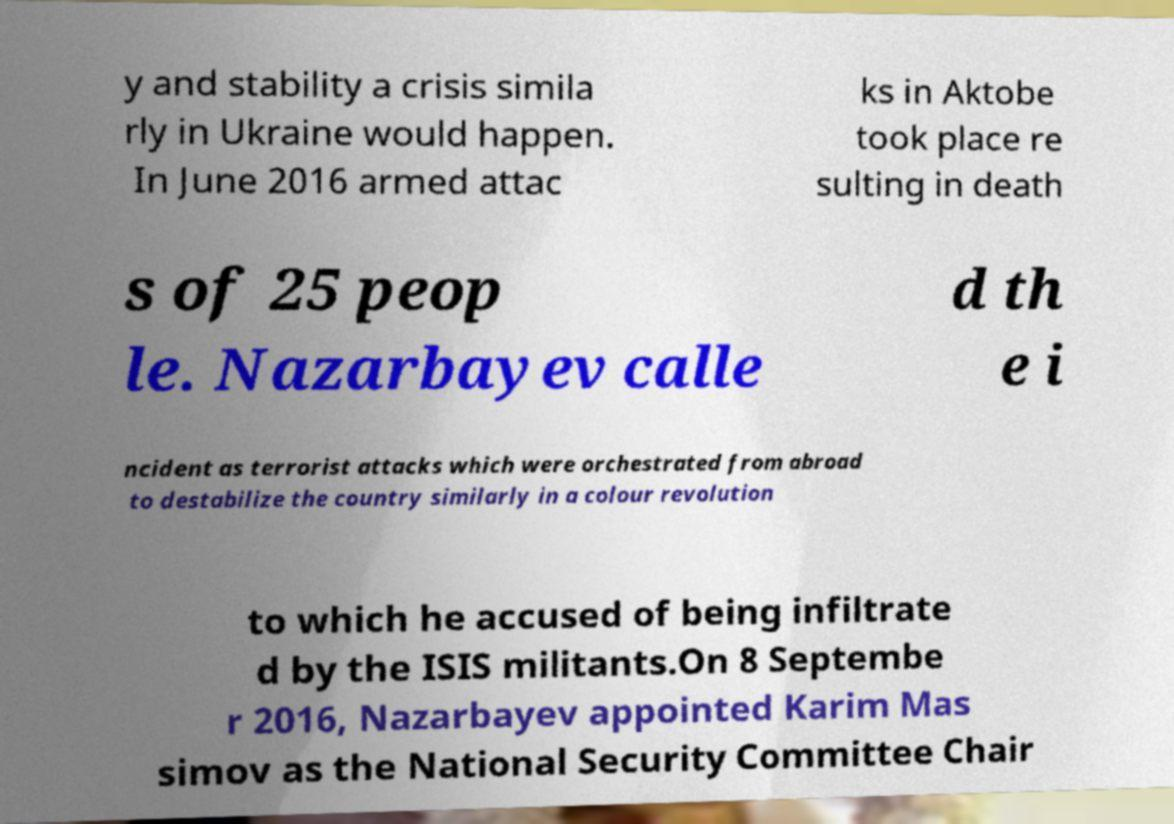Could you extract and type out the text from this image? y and stability a crisis simila rly in Ukraine would happen. In June 2016 armed attac ks in Aktobe took place re sulting in death s of 25 peop le. Nazarbayev calle d th e i ncident as terrorist attacks which were orchestrated from abroad to destabilize the country similarly in a colour revolution to which he accused of being infiltrate d by the ISIS militants.On 8 Septembe r 2016, Nazarbayev appointed Karim Mas simov as the National Security Committee Chair 